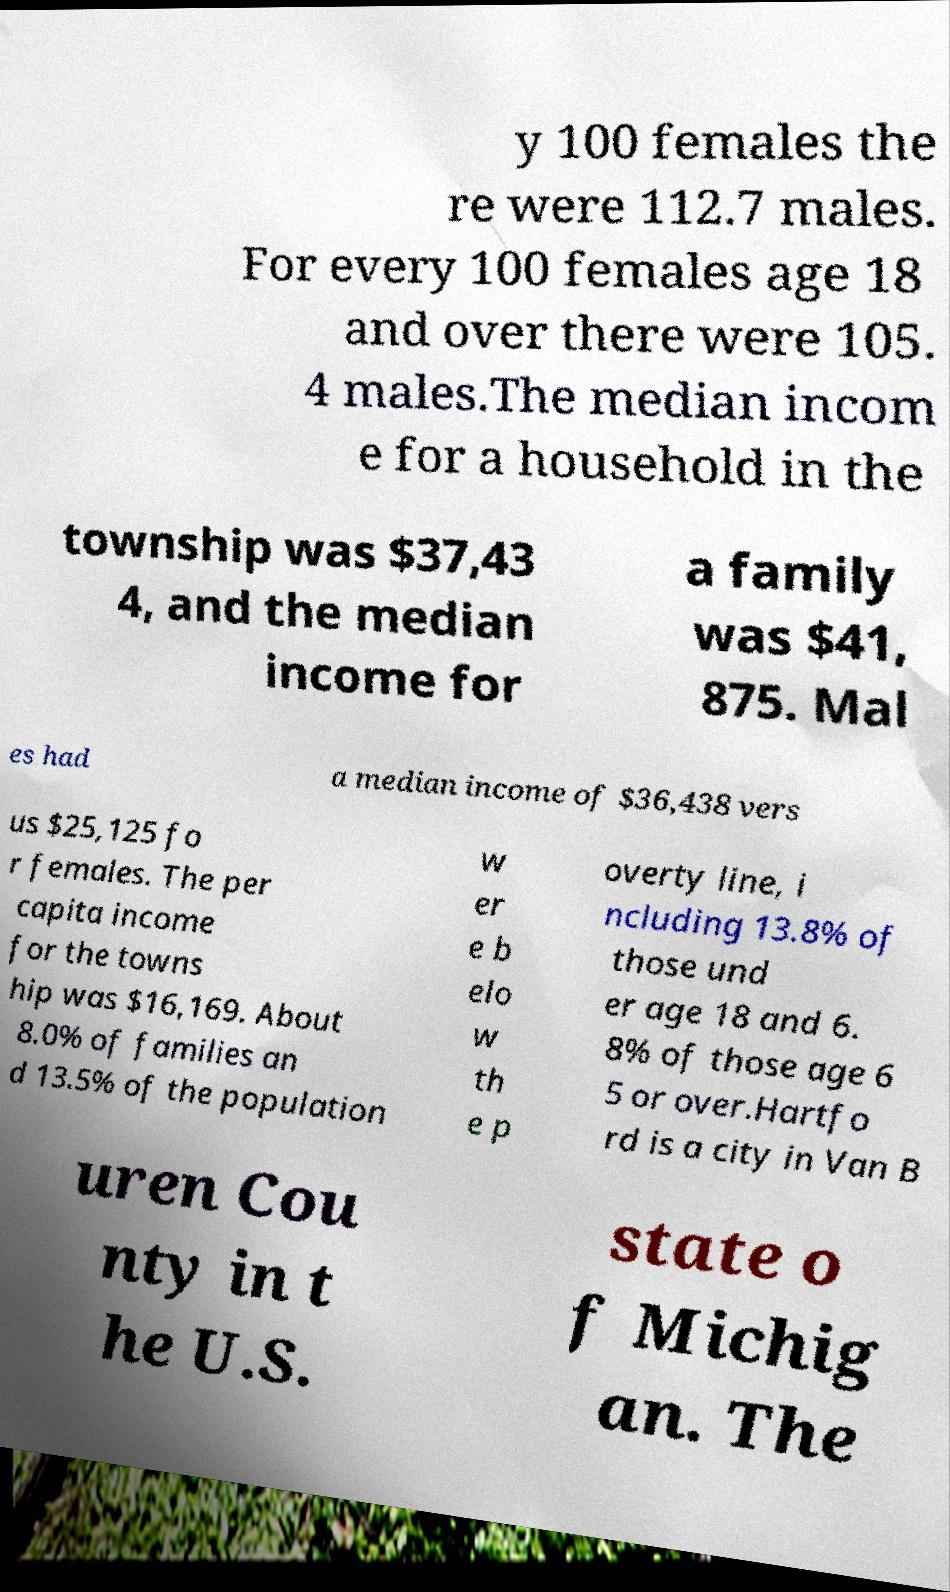Can you accurately transcribe the text from the provided image for me? y 100 females the re were 112.7 males. For every 100 females age 18 and over there were 105. 4 males.The median incom e for a household in the township was $37,43 4, and the median income for a family was $41, 875. Mal es had a median income of $36,438 vers us $25,125 fo r females. The per capita income for the towns hip was $16,169. About 8.0% of families an d 13.5% of the population w er e b elo w th e p overty line, i ncluding 13.8% of those und er age 18 and 6. 8% of those age 6 5 or over.Hartfo rd is a city in Van B uren Cou nty in t he U.S. state o f Michig an. The 